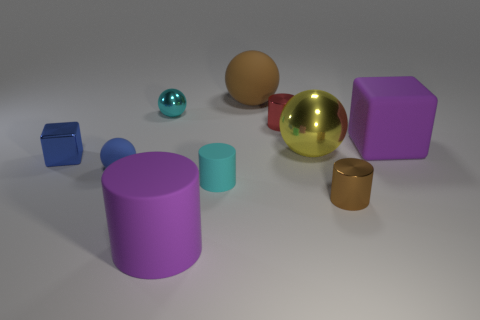Are the large yellow sphere and the brown thing to the right of the yellow shiny thing made of the same material?
Provide a short and direct response. Yes. There is a small object in front of the small cyan matte cylinder; what is its shape?
Provide a short and direct response. Cylinder. Are there an equal number of large yellow shiny cubes and small objects?
Keep it short and to the point. No. What number of other things are there of the same material as the brown cylinder
Provide a short and direct response. 4. The cyan metal thing has what size?
Your answer should be very brief. Small. What number of other things are there of the same color as the big cube?
Keep it short and to the point. 1. There is a thing that is both to the right of the cyan cylinder and behind the red metallic object; what color is it?
Offer a very short reply. Brown. What number of brown spheres are there?
Your answer should be very brief. 1. Does the blue sphere have the same material as the yellow ball?
Ensure brevity in your answer.  No. There is a large matte object behind the big purple matte object on the right side of the cyan object that is to the right of the large cylinder; what shape is it?
Ensure brevity in your answer.  Sphere. 